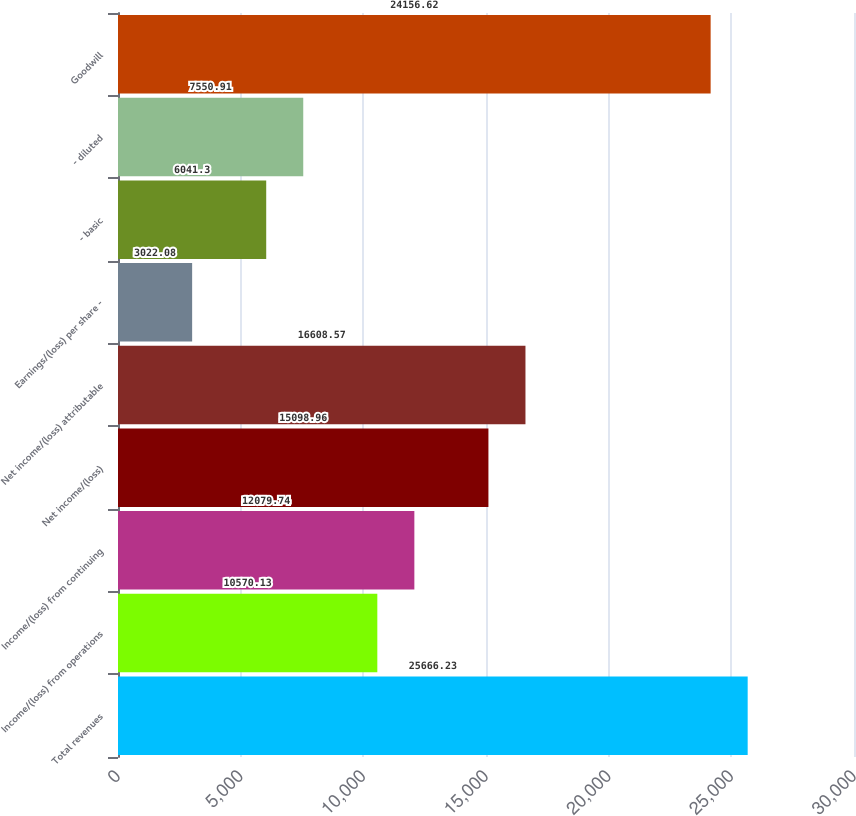<chart> <loc_0><loc_0><loc_500><loc_500><bar_chart><fcel>Total revenues<fcel>Income/(loss) from operations<fcel>Income/(loss) from continuing<fcel>Net income/(loss)<fcel>Net income/(loss) attributable<fcel>Earnings/(loss) per share -<fcel>- basic<fcel>- diluted<fcel>Goodwill<nl><fcel>25666.2<fcel>10570.1<fcel>12079.7<fcel>15099<fcel>16608.6<fcel>3022.08<fcel>6041.3<fcel>7550.91<fcel>24156.6<nl></chart> 